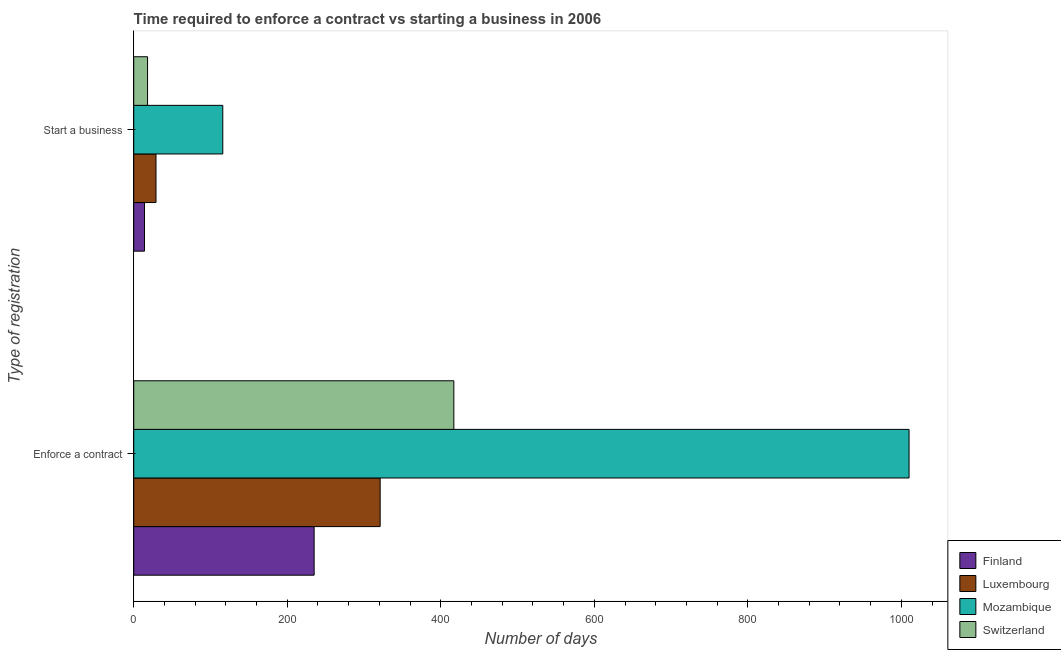How many different coloured bars are there?
Your answer should be compact. 4. How many bars are there on the 1st tick from the bottom?
Your response must be concise. 4. What is the label of the 1st group of bars from the top?
Your response must be concise. Start a business. What is the number of days to start a business in Mozambique?
Give a very brief answer. 116. Across all countries, what is the maximum number of days to enforece a contract?
Your answer should be compact. 1010. Across all countries, what is the minimum number of days to enforece a contract?
Offer a very short reply. 235. In which country was the number of days to start a business maximum?
Your answer should be compact. Mozambique. In which country was the number of days to enforece a contract minimum?
Offer a very short reply. Finland. What is the difference between the number of days to enforece a contract in Mozambique and that in Switzerland?
Offer a terse response. 593. What is the difference between the number of days to enforece a contract in Mozambique and the number of days to start a business in Luxembourg?
Make the answer very short. 981. What is the average number of days to enforece a contract per country?
Keep it short and to the point. 495.75. What is the difference between the number of days to start a business and number of days to enforece a contract in Luxembourg?
Provide a succinct answer. -292. What is the ratio of the number of days to start a business in Luxembourg to that in Switzerland?
Offer a very short reply. 1.61. Is the number of days to enforece a contract in Luxembourg less than that in Finland?
Keep it short and to the point. No. In how many countries, is the number of days to start a business greater than the average number of days to start a business taken over all countries?
Your response must be concise. 1. What does the 3rd bar from the bottom in Enforce a contract represents?
Ensure brevity in your answer.  Mozambique. How many bars are there?
Keep it short and to the point. 8. Are all the bars in the graph horizontal?
Provide a short and direct response. Yes. What is the difference between two consecutive major ticks on the X-axis?
Give a very brief answer. 200. Does the graph contain any zero values?
Provide a succinct answer. No. What is the title of the graph?
Give a very brief answer. Time required to enforce a contract vs starting a business in 2006. Does "Turks and Caicos Islands" appear as one of the legend labels in the graph?
Your answer should be very brief. No. What is the label or title of the X-axis?
Offer a terse response. Number of days. What is the label or title of the Y-axis?
Ensure brevity in your answer.  Type of registration. What is the Number of days of Finland in Enforce a contract?
Your response must be concise. 235. What is the Number of days in Luxembourg in Enforce a contract?
Make the answer very short. 321. What is the Number of days of Mozambique in Enforce a contract?
Your answer should be very brief. 1010. What is the Number of days of Switzerland in Enforce a contract?
Your answer should be very brief. 417. What is the Number of days in Finland in Start a business?
Ensure brevity in your answer.  14. What is the Number of days of Mozambique in Start a business?
Your answer should be compact. 116. Across all Type of registration, what is the maximum Number of days in Finland?
Offer a terse response. 235. Across all Type of registration, what is the maximum Number of days in Luxembourg?
Provide a succinct answer. 321. Across all Type of registration, what is the maximum Number of days in Mozambique?
Offer a terse response. 1010. Across all Type of registration, what is the maximum Number of days in Switzerland?
Your answer should be very brief. 417. Across all Type of registration, what is the minimum Number of days of Luxembourg?
Provide a succinct answer. 29. Across all Type of registration, what is the minimum Number of days in Mozambique?
Provide a short and direct response. 116. Across all Type of registration, what is the minimum Number of days of Switzerland?
Your answer should be compact. 18. What is the total Number of days in Finland in the graph?
Ensure brevity in your answer.  249. What is the total Number of days of Luxembourg in the graph?
Your response must be concise. 350. What is the total Number of days of Mozambique in the graph?
Your answer should be compact. 1126. What is the total Number of days of Switzerland in the graph?
Your answer should be compact. 435. What is the difference between the Number of days in Finland in Enforce a contract and that in Start a business?
Your answer should be very brief. 221. What is the difference between the Number of days of Luxembourg in Enforce a contract and that in Start a business?
Your response must be concise. 292. What is the difference between the Number of days in Mozambique in Enforce a contract and that in Start a business?
Offer a terse response. 894. What is the difference between the Number of days of Switzerland in Enforce a contract and that in Start a business?
Keep it short and to the point. 399. What is the difference between the Number of days of Finland in Enforce a contract and the Number of days of Luxembourg in Start a business?
Offer a terse response. 206. What is the difference between the Number of days of Finland in Enforce a contract and the Number of days of Mozambique in Start a business?
Provide a succinct answer. 119. What is the difference between the Number of days in Finland in Enforce a contract and the Number of days in Switzerland in Start a business?
Give a very brief answer. 217. What is the difference between the Number of days in Luxembourg in Enforce a contract and the Number of days in Mozambique in Start a business?
Provide a succinct answer. 205. What is the difference between the Number of days of Luxembourg in Enforce a contract and the Number of days of Switzerland in Start a business?
Your response must be concise. 303. What is the difference between the Number of days in Mozambique in Enforce a contract and the Number of days in Switzerland in Start a business?
Provide a short and direct response. 992. What is the average Number of days of Finland per Type of registration?
Provide a succinct answer. 124.5. What is the average Number of days in Luxembourg per Type of registration?
Keep it short and to the point. 175. What is the average Number of days in Mozambique per Type of registration?
Ensure brevity in your answer.  563. What is the average Number of days in Switzerland per Type of registration?
Offer a terse response. 217.5. What is the difference between the Number of days in Finland and Number of days in Luxembourg in Enforce a contract?
Offer a very short reply. -86. What is the difference between the Number of days of Finland and Number of days of Mozambique in Enforce a contract?
Provide a short and direct response. -775. What is the difference between the Number of days of Finland and Number of days of Switzerland in Enforce a contract?
Provide a short and direct response. -182. What is the difference between the Number of days of Luxembourg and Number of days of Mozambique in Enforce a contract?
Make the answer very short. -689. What is the difference between the Number of days of Luxembourg and Number of days of Switzerland in Enforce a contract?
Provide a succinct answer. -96. What is the difference between the Number of days of Mozambique and Number of days of Switzerland in Enforce a contract?
Offer a very short reply. 593. What is the difference between the Number of days of Finland and Number of days of Luxembourg in Start a business?
Make the answer very short. -15. What is the difference between the Number of days in Finland and Number of days in Mozambique in Start a business?
Offer a terse response. -102. What is the difference between the Number of days in Finland and Number of days in Switzerland in Start a business?
Ensure brevity in your answer.  -4. What is the difference between the Number of days in Luxembourg and Number of days in Mozambique in Start a business?
Provide a succinct answer. -87. What is the difference between the Number of days of Luxembourg and Number of days of Switzerland in Start a business?
Your answer should be compact. 11. What is the ratio of the Number of days in Finland in Enforce a contract to that in Start a business?
Keep it short and to the point. 16.79. What is the ratio of the Number of days of Luxembourg in Enforce a contract to that in Start a business?
Offer a terse response. 11.07. What is the ratio of the Number of days of Mozambique in Enforce a contract to that in Start a business?
Your response must be concise. 8.71. What is the ratio of the Number of days of Switzerland in Enforce a contract to that in Start a business?
Your answer should be compact. 23.17. What is the difference between the highest and the second highest Number of days in Finland?
Provide a short and direct response. 221. What is the difference between the highest and the second highest Number of days in Luxembourg?
Keep it short and to the point. 292. What is the difference between the highest and the second highest Number of days in Mozambique?
Your response must be concise. 894. What is the difference between the highest and the second highest Number of days in Switzerland?
Offer a very short reply. 399. What is the difference between the highest and the lowest Number of days of Finland?
Ensure brevity in your answer.  221. What is the difference between the highest and the lowest Number of days of Luxembourg?
Your response must be concise. 292. What is the difference between the highest and the lowest Number of days in Mozambique?
Your answer should be very brief. 894. What is the difference between the highest and the lowest Number of days in Switzerland?
Offer a terse response. 399. 